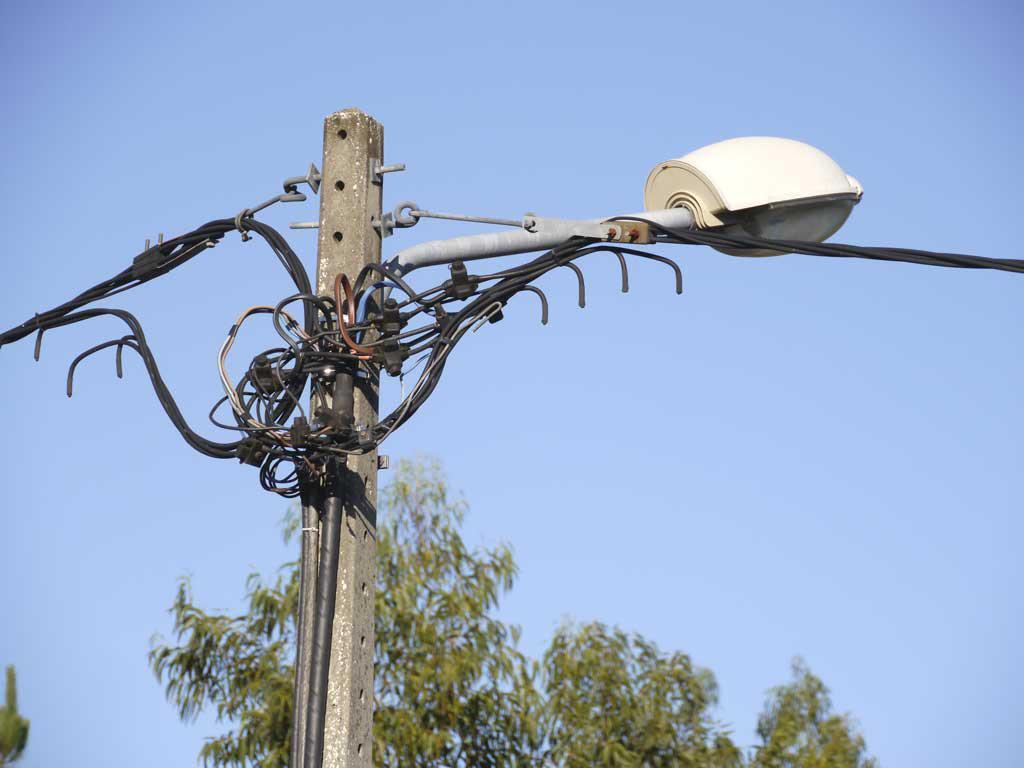What structure can be seen in the image? There is a light pole in the image. What is connected to the light pole? There are wires associated with the light pole. What can be seen in the background of the image? There is a tree in the background of the image. What is visible at the top of the image? The sky is visible at the top of the image. Reasoning: Let' Let's think step by step in order to produce the conversation. We start by identifying the main subject in the image, which is the light pole. Then, we expand the conversation to include other items that are also visible, such as the wires, the tree in the background, and the sky. Each question is designed to elicit a specific detail about the image that is known from the provided facts. Absurd Question/Answer: How many toes can be seen on the tree in the image? There are no toes visible in the image, as it features a light pole, wires, a tree, and the sky. 